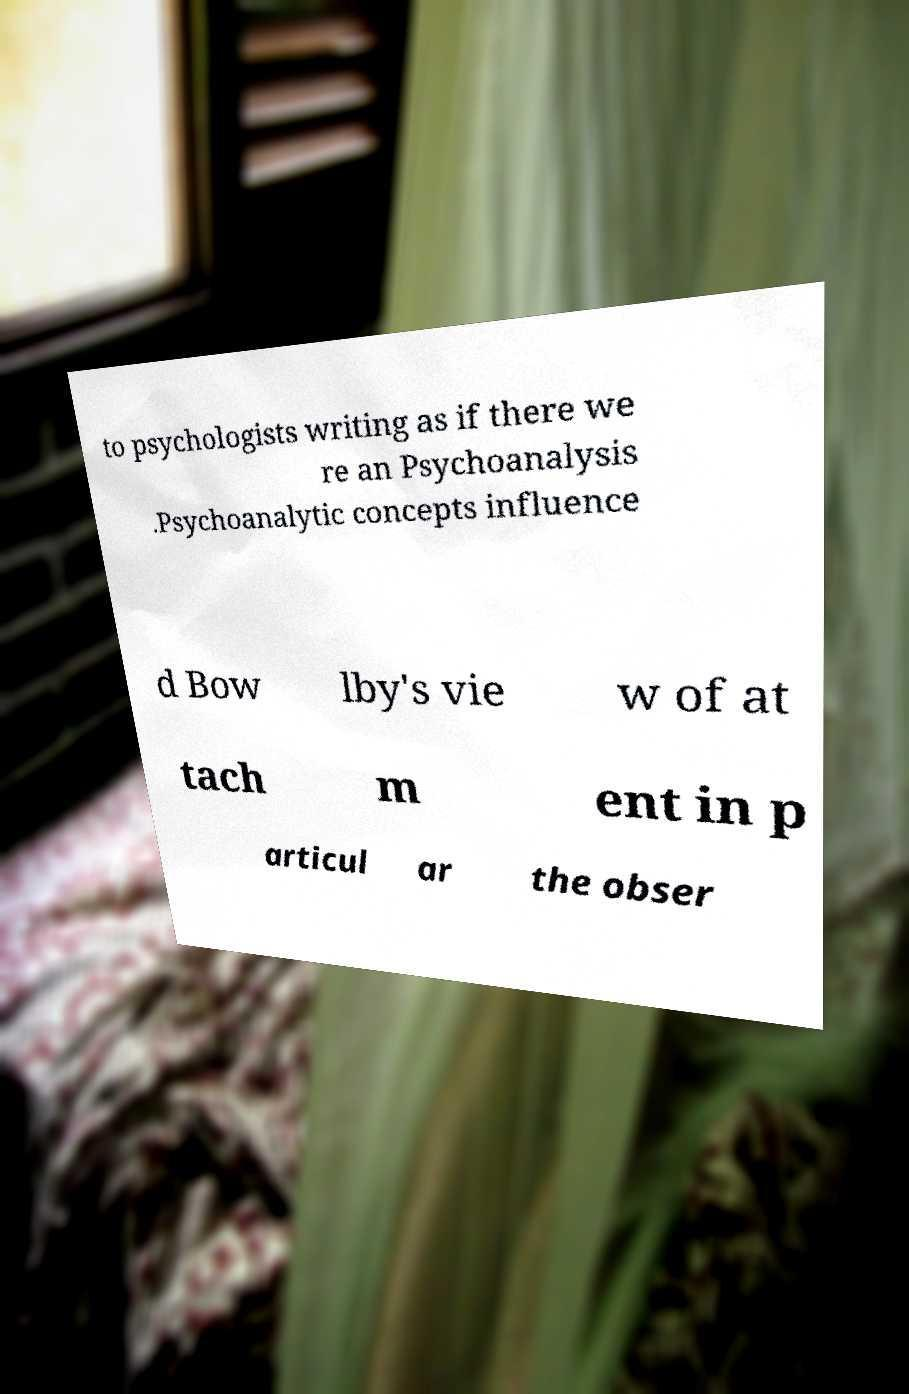Could you extract and type out the text from this image? to psychologists writing as if there we re an Psychoanalysis .Psychoanalytic concepts influence d Bow lby's vie w of at tach m ent in p articul ar the obser 